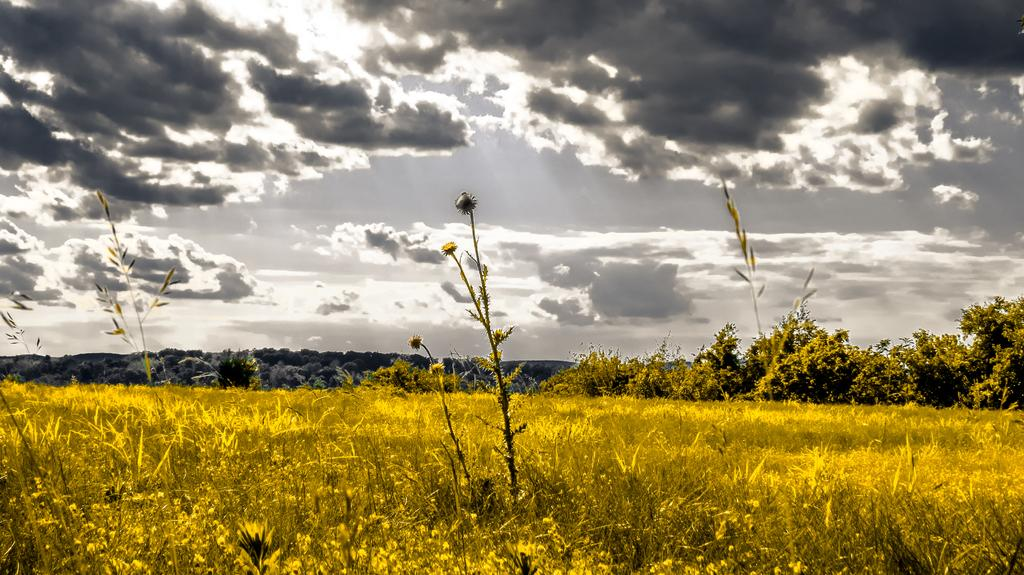What type of vegetation can be seen in the image? There are plants and trees in the image. Can you describe the sky in the image? The sky is cloudy in the image. How many bears are visible in the image? There are no bears present in the image. What type of sack can be seen hanging from the tree in the image? There is no sack present in the image; only plants, trees, and a cloudy sky are visible. 